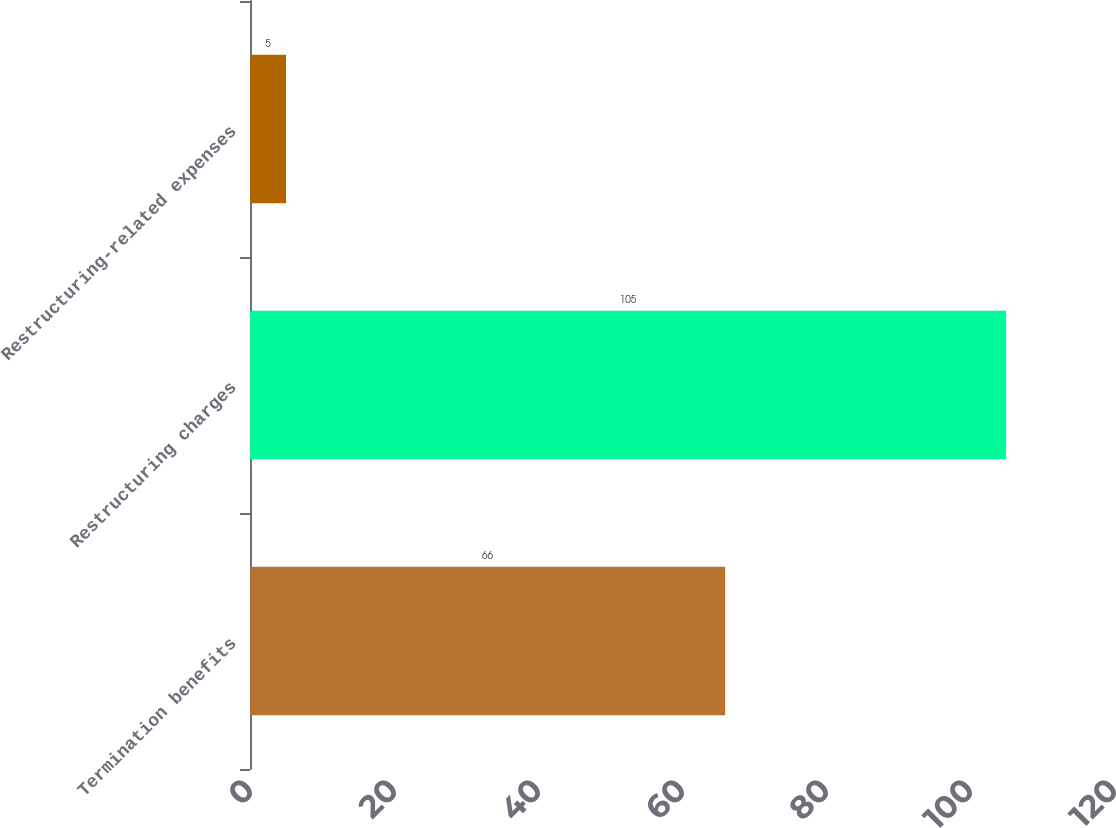<chart> <loc_0><loc_0><loc_500><loc_500><bar_chart><fcel>Termination benefits<fcel>Restructuring charges<fcel>Restructuring-related expenses<nl><fcel>66<fcel>105<fcel>5<nl></chart> 